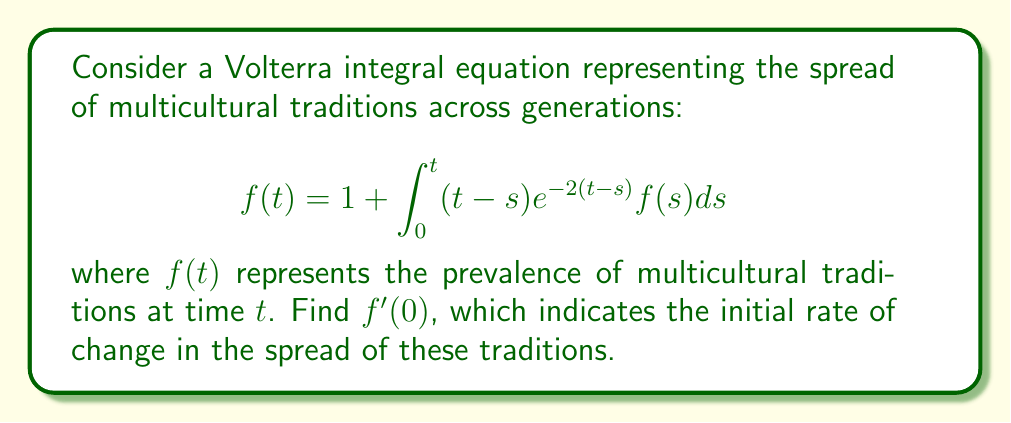Can you answer this question? To find $f'(0)$, we need to differentiate both sides of the equation with respect to $t$ and then evaluate at $t=0$. Let's proceed step by step:

1) Differentiate both sides of the equation:
   $$f'(t) = 0 + \frac{d}{dt}\int_0^t (t-s)e^{-2(t-s)}f(s)ds$$

2) Apply Leibniz's rule for differentiating under the integral sign:
   $$f'(t) = (t-t)e^{-2(t-t)}f(t) + \int_0^t \frac{\partial}{\partial t}[(t-s)e^{-2(t-s)}]f(s)ds$$

3) Simplify:
   $$f'(t) = 0 + \int_0^t [e^{-2(t-s)} - 2(t-s)e^{-2(t-s)}]f(s)ds$$

4) Now, evaluate at $t=0$:
   $$f'(0) = \int_0^0 [e^{-2(0-s)} - 2(0-s)e^{-2(0-s)}]f(s)ds = 0$$

5) Therefore, $f'(0) = 0$

This result indicates that at the initial moment, there is no change in the spread of multicultural traditions. The rate of change starts at zero and will likely increase as time progresses.
Answer: $f'(0) = 0$ 